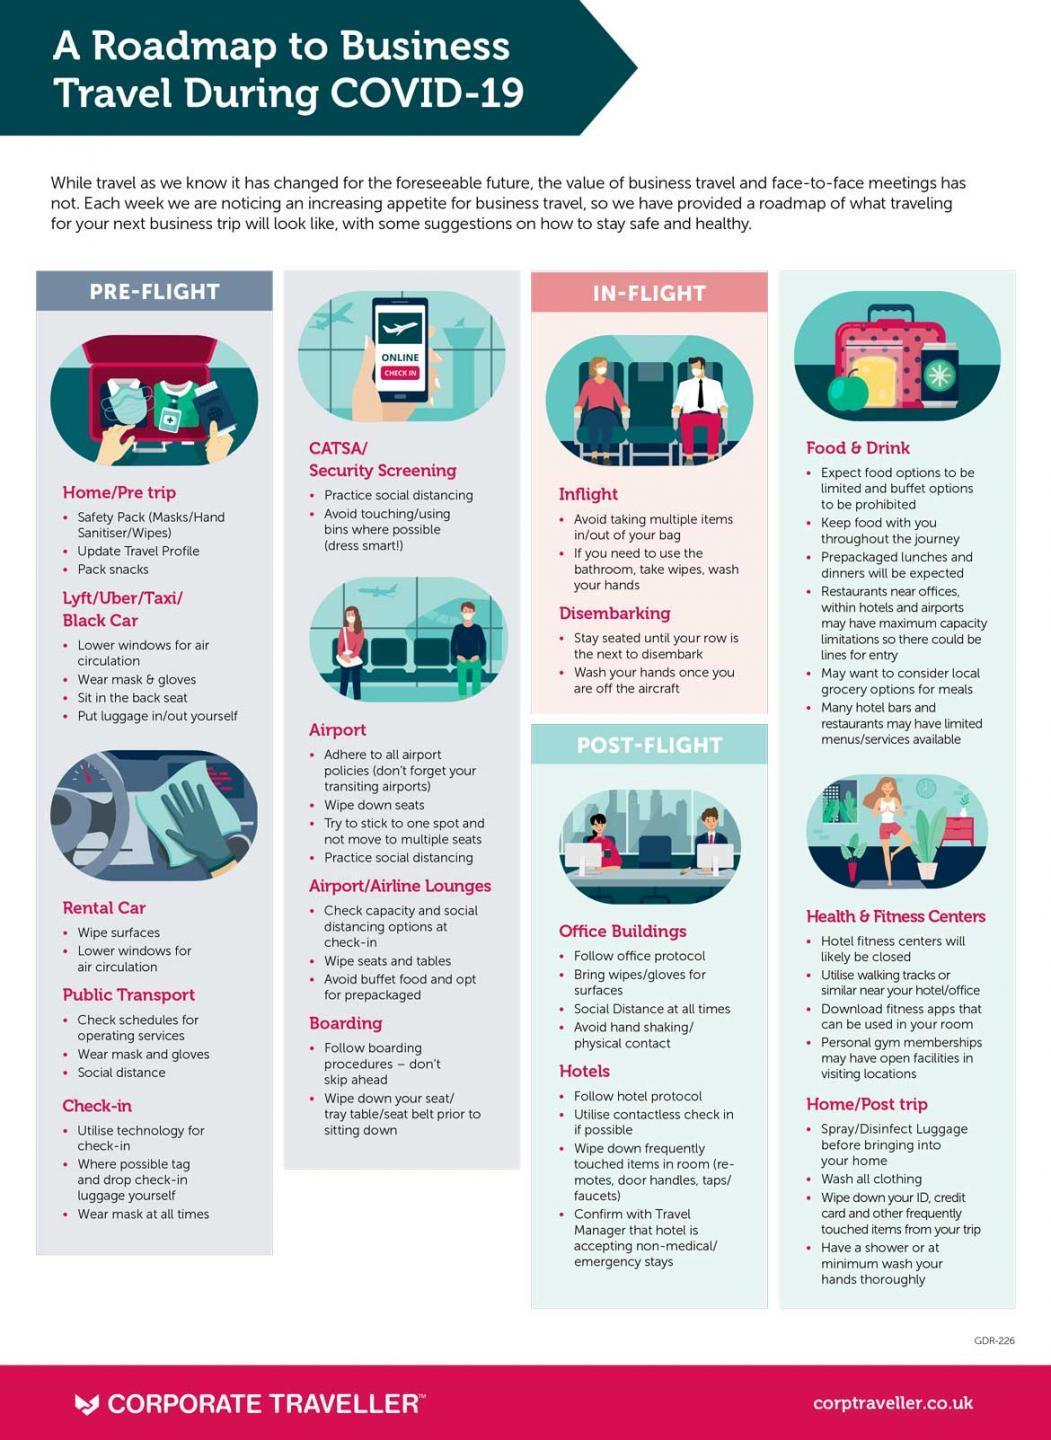In how many places should you practice social distancing?
Answer the question with a short phrase. 5 In how many places should you wear mask? 3 